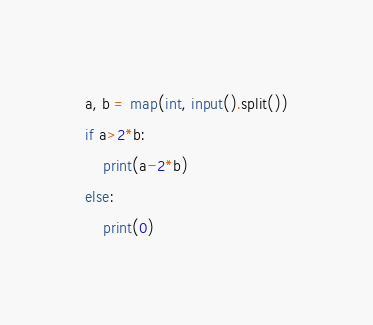Convert code to text. <code><loc_0><loc_0><loc_500><loc_500><_Python_>a, b = map(int, input().split())
if a>2*b:
	print(a-2*b)
else:
	print(0)</code> 